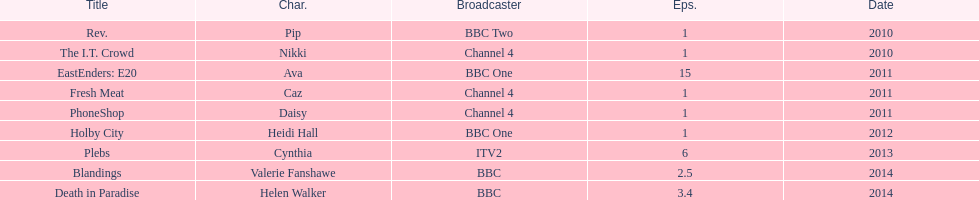Were there more than four episodes that featured cynthia? Yes. 